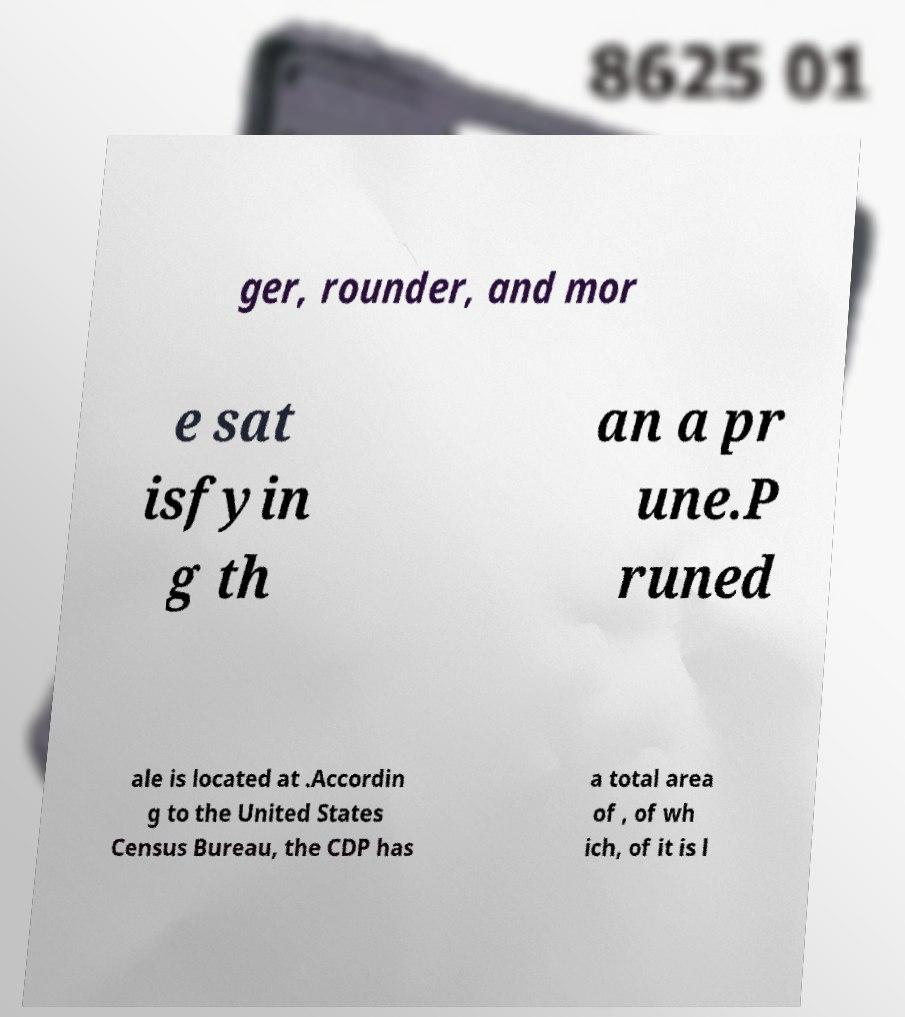What messages or text are displayed in this image? I need them in a readable, typed format. ger, rounder, and mor e sat isfyin g th an a pr une.P runed ale is located at .Accordin g to the United States Census Bureau, the CDP has a total area of , of wh ich, of it is l 